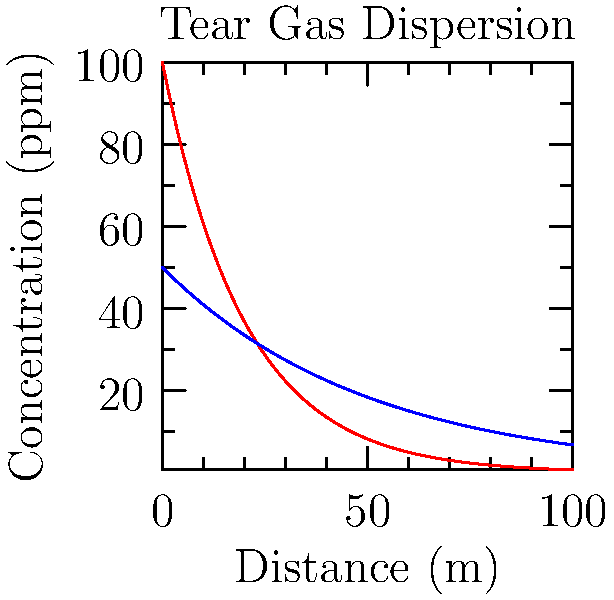In an open space, tear gas is released at an initial concentration of 100 ppm. The graph shows the concentration decay over distance for two wind conditions. If the minimum concentration for effectiveness is 10 ppm, how much farther does the tear gas remain effective in low wind conditions compared to high wind conditions? To solve this problem, we need to follow these steps:

1) The effectiveness threshold is 10 ppm. We need to find where each curve crosses this line.

2) For high wind speed (red curve):
   $100 * e^{-0.05x} = 10$
   $e^{-0.05x} = 0.1$
   $-0.05x = ln(0.1)$
   $x = -ln(0.1)/0.05 \approx 46.05$ meters

3) For low wind speed (blue curve):
   $50 * e^{-0.02x} = 10$
   $e^{-0.02x} = 0.2$
   $-0.02x = ln(0.2)$
   $x = -ln(0.2)/0.02 \approx 80.47$ meters

4) The difference in effective distance:
   $80.47 - 46.05 = 34.42$ meters

Therefore, in low wind conditions, the tear gas remains effective for about 34.42 meters farther than in high wind conditions.
Answer: 34.42 meters 